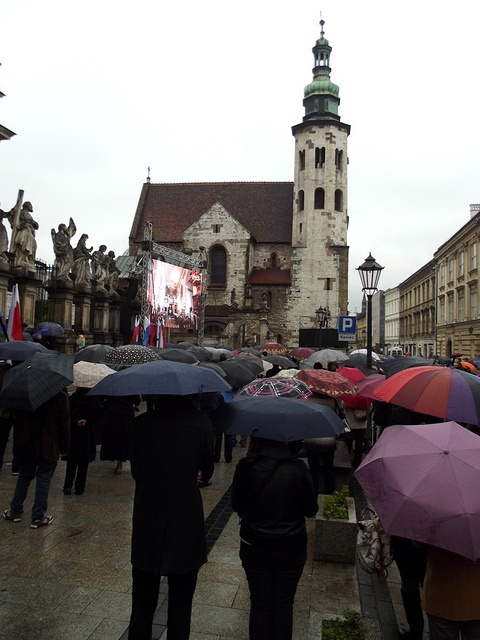Describe the objects in this image and their specific colors. I can see people in white, black, and gray tones, people in white, black, and gray tones, umbrella in white, purple, black, and gray tones, people in white, black, and gray tones, and people in white, black, and gray tones in this image. 